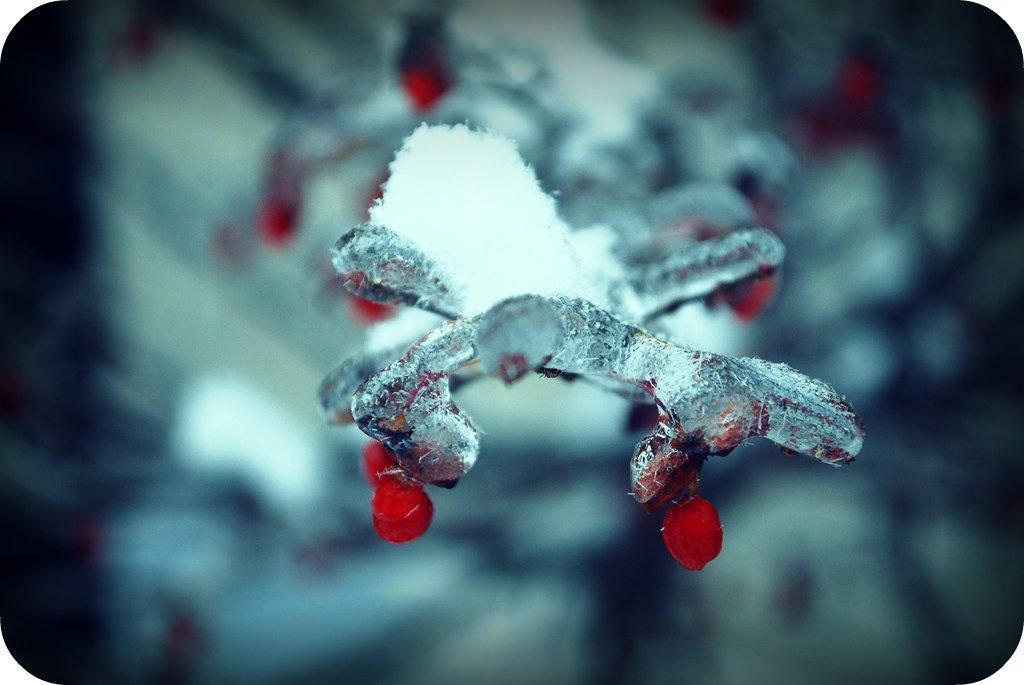Please provide a concise description of this image. As we can see in the image in the front there is front and the background is blurred. 